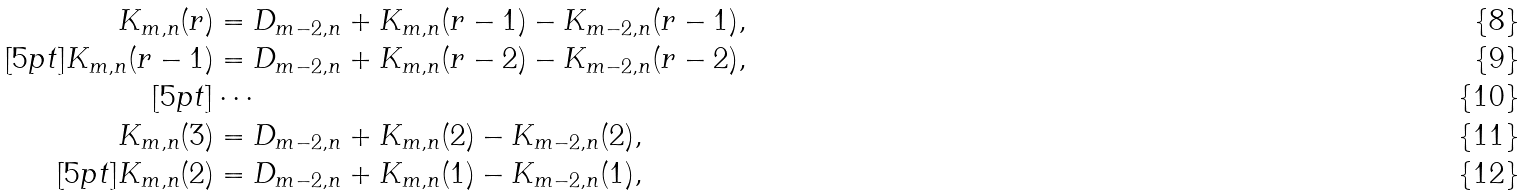<formula> <loc_0><loc_0><loc_500><loc_500>K _ { m , n } ( r ) & = D _ { m - 2 , n } + K _ { m , n } ( r - 1 ) - K _ { m - 2 , n } ( r - 1 ) , \\ [ 5 p t ] K _ { m , n } ( r - 1 ) & = D _ { m - 2 , n } + K _ { m , n } ( r - 2 ) - K _ { m - 2 , n } ( r - 2 ) , \\ [ 5 p t ] & \cdots \\ K _ { m , n } ( 3 ) & = D _ { m - 2 , n } + K _ { m , n } ( 2 ) - K _ { m - 2 , n } ( 2 ) , \\ [ 5 p t ] K _ { m , n } ( 2 ) & = D _ { m - 2 , n } + K _ { m , n } ( 1 ) - K _ { m - 2 , n } ( 1 ) ,</formula> 